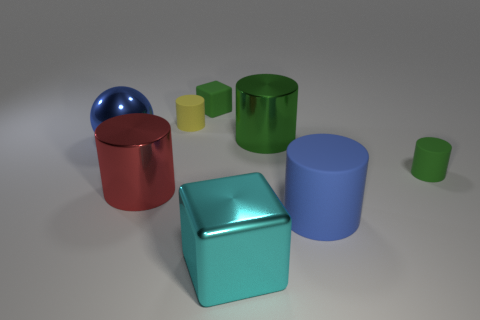The metal thing that is the same color as the small cube is what size?
Give a very brief answer. Large. The metallic thing that is the same color as the big rubber thing is what shape?
Give a very brief answer. Sphere. Do the large red metal object and the big blue object that is behind the blue matte object have the same shape?
Provide a short and direct response. No. How many other things are the same material as the tiny yellow object?
Provide a succinct answer. 3. The big metal cylinder that is left of the metal cylinder that is to the right of the large cyan metallic block that is in front of the big blue metal sphere is what color?
Provide a succinct answer. Red. What shape is the tiny green thing right of the block to the left of the cyan metallic thing?
Offer a terse response. Cylinder. Is the number of rubber cylinders that are on the right side of the large blue rubber cylinder greater than the number of small rubber cubes?
Offer a terse response. No. There is a shiny thing that is on the left side of the large red metal object; is its shape the same as the red shiny thing?
Provide a succinct answer. No. Are there any yellow matte objects of the same shape as the red shiny object?
Offer a terse response. Yes. What number of objects are either cylinders that are behind the ball or green metal blocks?
Ensure brevity in your answer.  2. 